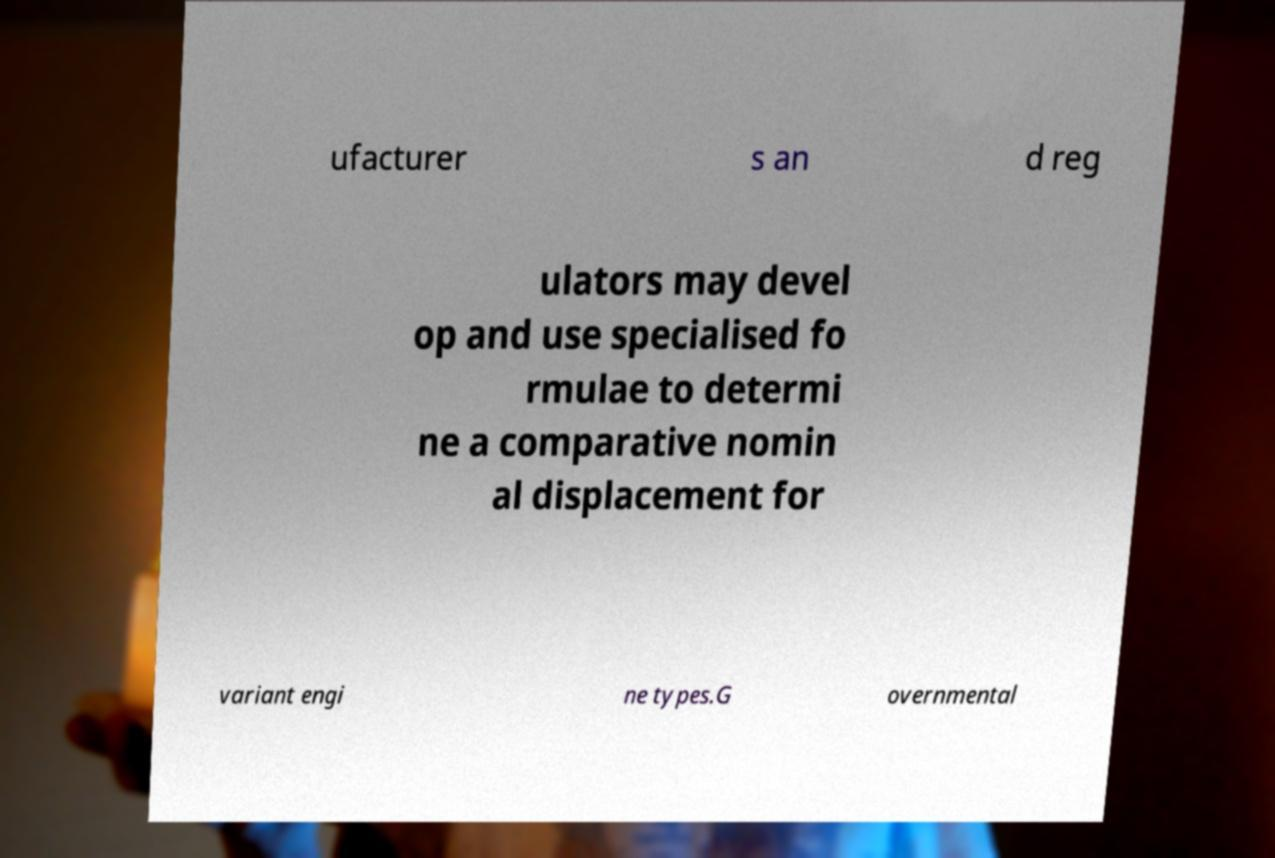Could you extract and type out the text from this image? ufacturer s an d reg ulators may devel op and use specialised fo rmulae to determi ne a comparative nomin al displacement for variant engi ne types.G overnmental 